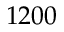Convert formula to latex. <formula><loc_0><loc_0><loc_500><loc_500>1 2 0 0</formula> 